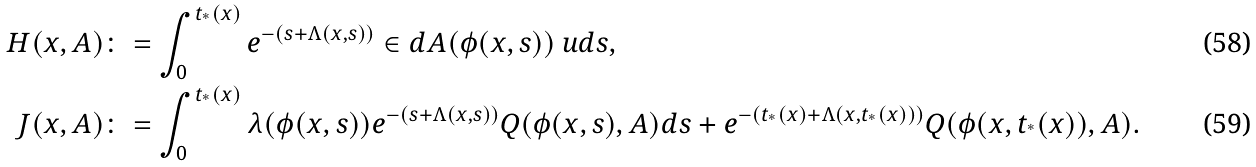Convert formula to latex. <formula><loc_0><loc_0><loc_500><loc_500>H ( x , A ) & \colon = \int _ { 0 } ^ { t _ { ^ { * } } ( x ) } e ^ { - ( s + \Lambda ( x , s ) ) } \in d { A } ( \phi ( x , s ) ) \ u d s , \\ J ( x , A ) & \colon = \int _ { 0 } ^ { t _ { ^ { * } } ( x ) } \lambda ( \phi ( x , s ) ) e ^ { - ( s + \Lambda ( x , s ) ) } Q ( \phi ( x , s ) , A ) d s + e ^ { - ( t _ { ^ { * } } ( x ) + \Lambda ( x , t _ { ^ { * } } ( x ) ) ) } Q ( \phi ( x , t _ { ^ { * } } ( x ) ) , A ) .</formula> 